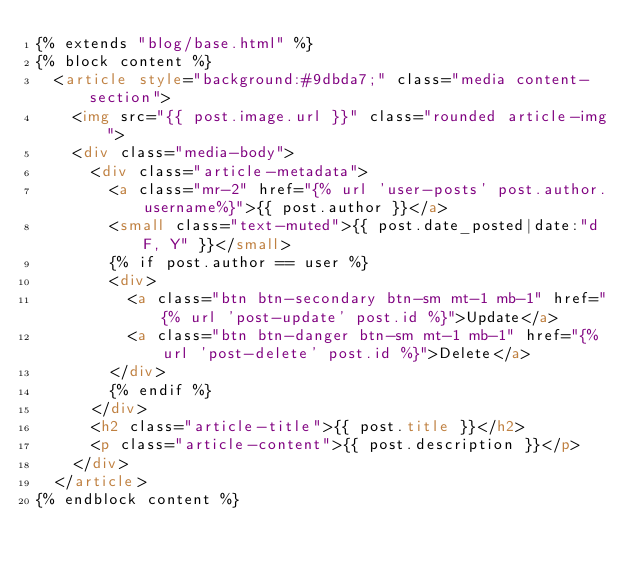<code> <loc_0><loc_0><loc_500><loc_500><_HTML_>{% extends "blog/base.html" %}
{% block content %}
  <article style="background:#9dbda7;" class="media content-section">
    <img src="{{ post.image.url }}" class="rounded article-img">
    <div class="media-body">
      <div class="article-metadata">
        <a class="mr-2" href="{% url 'user-posts' post.author.username%}">{{ post.author }}</a>
        <small class="text-muted">{{ post.date_posted|date:"d F, Y" }}</small>
        {% if post.author == user %}
        <div>
          <a class="btn btn-secondary btn-sm mt-1 mb-1" href="{% url 'post-update' post.id %}">Update</a>
          <a class="btn btn-danger btn-sm mt-1 mb-1" href="{% url 'post-delete' post.id %}">Delete</a>
        </div>
        {% endif %}
      </div>
      <h2 class="article-title">{{ post.title }}</h2>
      <p class="article-content">{{ post.description }}</p>
    </div>
  </article>
{% endblock content %}
</code> 